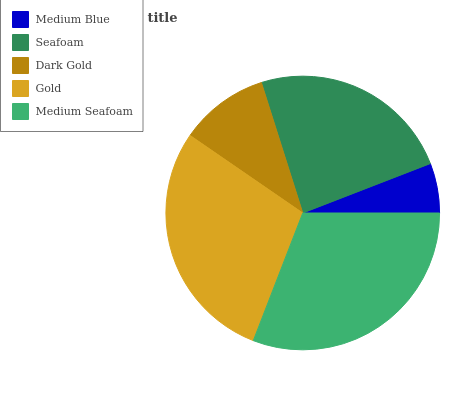Is Medium Blue the minimum?
Answer yes or no. Yes. Is Medium Seafoam the maximum?
Answer yes or no. Yes. Is Seafoam the minimum?
Answer yes or no. No. Is Seafoam the maximum?
Answer yes or no. No. Is Seafoam greater than Medium Blue?
Answer yes or no. Yes. Is Medium Blue less than Seafoam?
Answer yes or no. Yes. Is Medium Blue greater than Seafoam?
Answer yes or no. No. Is Seafoam less than Medium Blue?
Answer yes or no. No. Is Seafoam the high median?
Answer yes or no. Yes. Is Seafoam the low median?
Answer yes or no. Yes. Is Dark Gold the high median?
Answer yes or no. No. Is Medium Blue the low median?
Answer yes or no. No. 